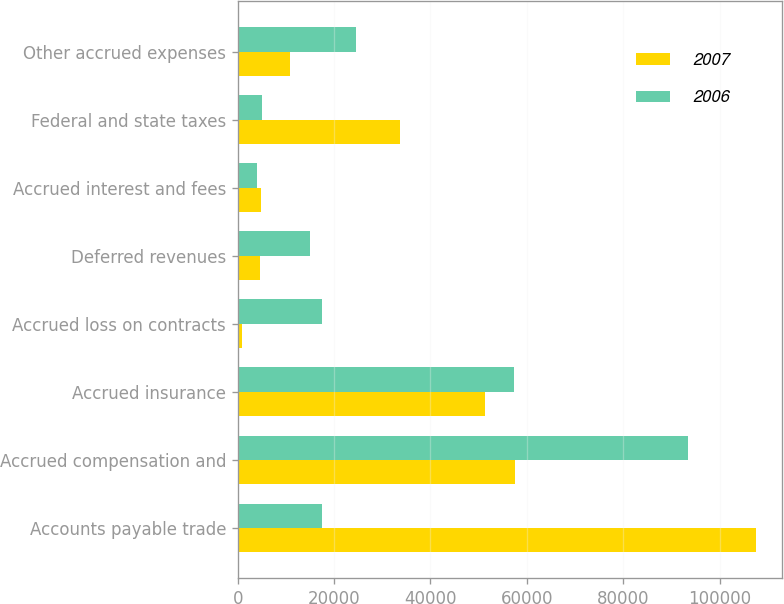Convert chart to OTSL. <chart><loc_0><loc_0><loc_500><loc_500><stacked_bar_chart><ecel><fcel>Accounts payable trade<fcel>Accrued compensation and<fcel>Accrued insurance<fcel>Accrued loss on contracts<fcel>Deferred revenues<fcel>Accrued interest and fees<fcel>Federal and state taxes<fcel>Other accrued expenses<nl><fcel>2007<fcel>107484<fcel>57522<fcel>51287<fcel>876<fcel>4569<fcel>4726<fcel>33628<fcel>10805<nl><fcel>2006<fcel>17553<fcel>93509<fcel>57325<fcel>17553<fcel>15021<fcel>4097<fcel>5049<fcel>24487<nl></chart> 